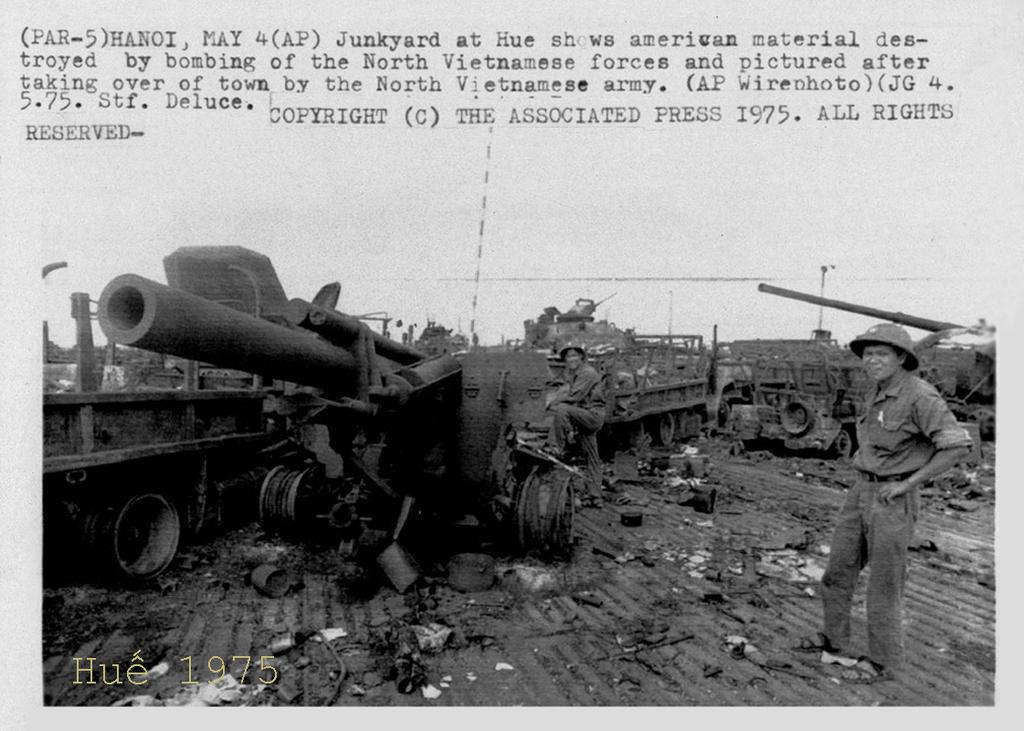<image>
Provide a brief description of the given image. a black and white image of Vietnamese soldiers at Hue in 1975 